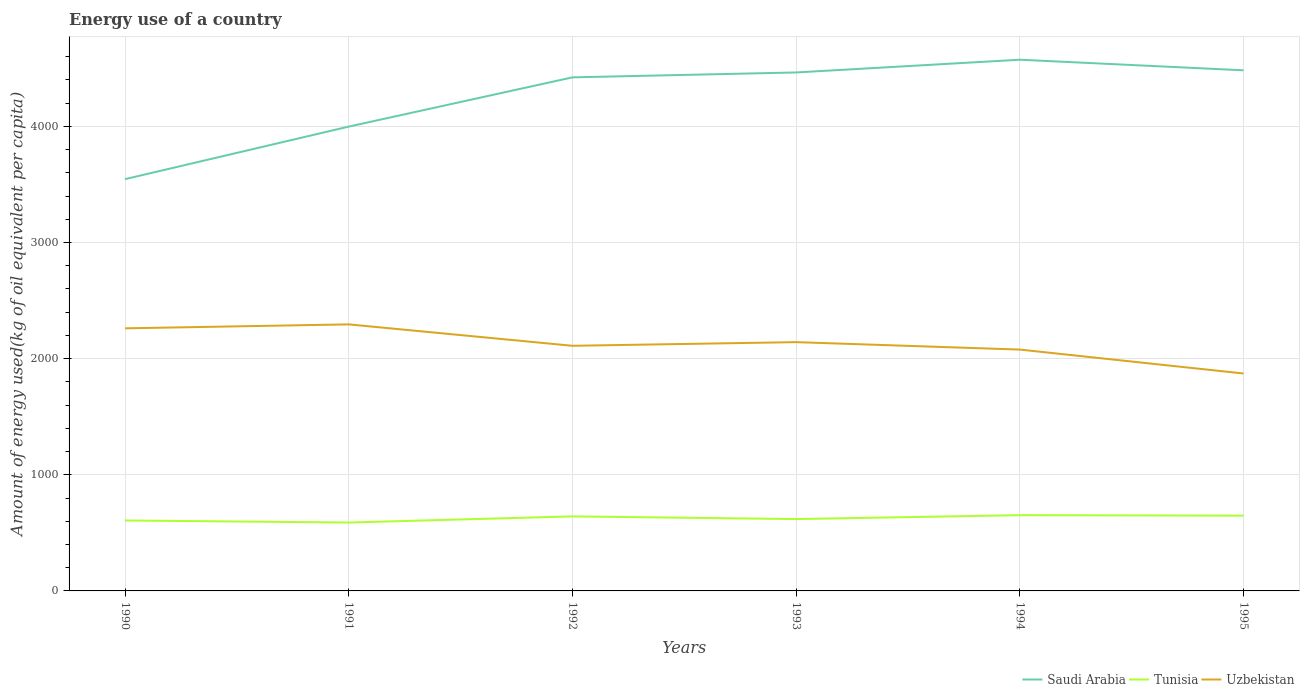How many different coloured lines are there?
Provide a short and direct response. 3. Is the number of lines equal to the number of legend labels?
Your answer should be very brief. Yes. Across all years, what is the maximum amount of energy used in in Saudi Arabia?
Ensure brevity in your answer.  3545.24. In which year was the amount of energy used in in Uzbekistan maximum?
Your answer should be compact. 1995. What is the total amount of energy used in in Tunisia in the graph?
Offer a very short reply. -12.02. What is the difference between the highest and the second highest amount of energy used in in Saudi Arabia?
Keep it short and to the point. 1028.2. What is the difference between the highest and the lowest amount of energy used in in Tunisia?
Offer a very short reply. 3. Is the amount of energy used in in Saudi Arabia strictly greater than the amount of energy used in in Uzbekistan over the years?
Your answer should be compact. No. How many lines are there?
Provide a succinct answer. 3. How many years are there in the graph?
Your response must be concise. 6. What is the difference between two consecutive major ticks on the Y-axis?
Your answer should be very brief. 1000. Are the values on the major ticks of Y-axis written in scientific E-notation?
Offer a very short reply. No. Does the graph contain grids?
Offer a very short reply. Yes. How many legend labels are there?
Offer a very short reply. 3. How are the legend labels stacked?
Your answer should be compact. Horizontal. What is the title of the graph?
Offer a very short reply. Energy use of a country. What is the label or title of the Y-axis?
Offer a terse response. Amount of energy used(kg of oil equivalent per capita). What is the Amount of energy used(kg of oil equivalent per capita) in Saudi Arabia in 1990?
Offer a very short reply. 3545.24. What is the Amount of energy used(kg of oil equivalent per capita) of Tunisia in 1990?
Keep it short and to the point. 606.56. What is the Amount of energy used(kg of oil equivalent per capita) of Uzbekistan in 1990?
Make the answer very short. 2260.77. What is the Amount of energy used(kg of oil equivalent per capita) of Saudi Arabia in 1991?
Your answer should be very brief. 3997.62. What is the Amount of energy used(kg of oil equivalent per capita) of Tunisia in 1991?
Make the answer very short. 588.87. What is the Amount of energy used(kg of oil equivalent per capita) of Uzbekistan in 1991?
Your answer should be compact. 2294.82. What is the Amount of energy used(kg of oil equivalent per capita) of Saudi Arabia in 1992?
Make the answer very short. 4421.51. What is the Amount of energy used(kg of oil equivalent per capita) in Tunisia in 1992?
Give a very brief answer. 641.69. What is the Amount of energy used(kg of oil equivalent per capita) in Uzbekistan in 1992?
Give a very brief answer. 2110.5. What is the Amount of energy used(kg of oil equivalent per capita) in Saudi Arabia in 1993?
Keep it short and to the point. 4463.81. What is the Amount of energy used(kg of oil equivalent per capita) in Tunisia in 1993?
Your answer should be compact. 618.59. What is the Amount of energy used(kg of oil equivalent per capita) in Uzbekistan in 1993?
Your answer should be very brief. 2141.93. What is the Amount of energy used(kg of oil equivalent per capita) in Saudi Arabia in 1994?
Offer a very short reply. 4573.44. What is the Amount of energy used(kg of oil equivalent per capita) of Tunisia in 1994?
Provide a short and direct response. 652.31. What is the Amount of energy used(kg of oil equivalent per capita) in Uzbekistan in 1994?
Offer a terse response. 2077.89. What is the Amount of energy used(kg of oil equivalent per capita) in Saudi Arabia in 1995?
Your answer should be very brief. 4482.28. What is the Amount of energy used(kg of oil equivalent per capita) in Tunisia in 1995?
Your response must be concise. 647.98. What is the Amount of energy used(kg of oil equivalent per capita) in Uzbekistan in 1995?
Make the answer very short. 1871.85. Across all years, what is the maximum Amount of energy used(kg of oil equivalent per capita) of Saudi Arabia?
Provide a succinct answer. 4573.44. Across all years, what is the maximum Amount of energy used(kg of oil equivalent per capita) in Tunisia?
Offer a terse response. 652.31. Across all years, what is the maximum Amount of energy used(kg of oil equivalent per capita) of Uzbekistan?
Ensure brevity in your answer.  2294.82. Across all years, what is the minimum Amount of energy used(kg of oil equivalent per capita) in Saudi Arabia?
Offer a very short reply. 3545.24. Across all years, what is the minimum Amount of energy used(kg of oil equivalent per capita) of Tunisia?
Make the answer very short. 588.87. Across all years, what is the minimum Amount of energy used(kg of oil equivalent per capita) in Uzbekistan?
Your response must be concise. 1871.85. What is the total Amount of energy used(kg of oil equivalent per capita) in Saudi Arabia in the graph?
Make the answer very short. 2.55e+04. What is the total Amount of energy used(kg of oil equivalent per capita) of Tunisia in the graph?
Your response must be concise. 3756.01. What is the total Amount of energy used(kg of oil equivalent per capita) in Uzbekistan in the graph?
Ensure brevity in your answer.  1.28e+04. What is the difference between the Amount of energy used(kg of oil equivalent per capita) of Saudi Arabia in 1990 and that in 1991?
Provide a short and direct response. -452.37. What is the difference between the Amount of energy used(kg of oil equivalent per capita) in Tunisia in 1990 and that in 1991?
Offer a terse response. 17.7. What is the difference between the Amount of energy used(kg of oil equivalent per capita) in Uzbekistan in 1990 and that in 1991?
Keep it short and to the point. -34.06. What is the difference between the Amount of energy used(kg of oil equivalent per capita) of Saudi Arabia in 1990 and that in 1992?
Provide a succinct answer. -876.27. What is the difference between the Amount of energy used(kg of oil equivalent per capita) in Tunisia in 1990 and that in 1992?
Offer a very short reply. -35.13. What is the difference between the Amount of energy used(kg of oil equivalent per capita) in Uzbekistan in 1990 and that in 1992?
Your response must be concise. 150.27. What is the difference between the Amount of energy used(kg of oil equivalent per capita) of Saudi Arabia in 1990 and that in 1993?
Give a very brief answer. -918.57. What is the difference between the Amount of energy used(kg of oil equivalent per capita) in Tunisia in 1990 and that in 1993?
Offer a very short reply. -12.02. What is the difference between the Amount of energy used(kg of oil equivalent per capita) of Uzbekistan in 1990 and that in 1993?
Ensure brevity in your answer.  118.83. What is the difference between the Amount of energy used(kg of oil equivalent per capita) in Saudi Arabia in 1990 and that in 1994?
Provide a succinct answer. -1028.2. What is the difference between the Amount of energy used(kg of oil equivalent per capita) in Tunisia in 1990 and that in 1994?
Give a very brief answer. -45.75. What is the difference between the Amount of energy used(kg of oil equivalent per capita) in Uzbekistan in 1990 and that in 1994?
Offer a terse response. 182.88. What is the difference between the Amount of energy used(kg of oil equivalent per capita) of Saudi Arabia in 1990 and that in 1995?
Ensure brevity in your answer.  -937.04. What is the difference between the Amount of energy used(kg of oil equivalent per capita) of Tunisia in 1990 and that in 1995?
Offer a terse response. -41.42. What is the difference between the Amount of energy used(kg of oil equivalent per capita) in Uzbekistan in 1990 and that in 1995?
Provide a succinct answer. 388.92. What is the difference between the Amount of energy used(kg of oil equivalent per capita) of Saudi Arabia in 1991 and that in 1992?
Make the answer very short. -423.89. What is the difference between the Amount of energy used(kg of oil equivalent per capita) of Tunisia in 1991 and that in 1992?
Your response must be concise. -52.82. What is the difference between the Amount of energy used(kg of oil equivalent per capita) in Uzbekistan in 1991 and that in 1992?
Your response must be concise. 184.33. What is the difference between the Amount of energy used(kg of oil equivalent per capita) in Saudi Arabia in 1991 and that in 1993?
Provide a short and direct response. -466.19. What is the difference between the Amount of energy used(kg of oil equivalent per capita) of Tunisia in 1991 and that in 1993?
Offer a very short reply. -29.72. What is the difference between the Amount of energy used(kg of oil equivalent per capita) of Uzbekistan in 1991 and that in 1993?
Provide a succinct answer. 152.89. What is the difference between the Amount of energy used(kg of oil equivalent per capita) in Saudi Arabia in 1991 and that in 1994?
Your response must be concise. -575.83. What is the difference between the Amount of energy used(kg of oil equivalent per capita) in Tunisia in 1991 and that in 1994?
Keep it short and to the point. -63.45. What is the difference between the Amount of energy used(kg of oil equivalent per capita) of Uzbekistan in 1991 and that in 1994?
Ensure brevity in your answer.  216.93. What is the difference between the Amount of energy used(kg of oil equivalent per capita) of Saudi Arabia in 1991 and that in 1995?
Make the answer very short. -484.67. What is the difference between the Amount of energy used(kg of oil equivalent per capita) in Tunisia in 1991 and that in 1995?
Offer a very short reply. -59.12. What is the difference between the Amount of energy used(kg of oil equivalent per capita) in Uzbekistan in 1991 and that in 1995?
Offer a very short reply. 422.97. What is the difference between the Amount of energy used(kg of oil equivalent per capita) of Saudi Arabia in 1992 and that in 1993?
Your answer should be compact. -42.3. What is the difference between the Amount of energy used(kg of oil equivalent per capita) in Tunisia in 1992 and that in 1993?
Your response must be concise. 23.1. What is the difference between the Amount of energy used(kg of oil equivalent per capita) of Uzbekistan in 1992 and that in 1993?
Your response must be concise. -31.44. What is the difference between the Amount of energy used(kg of oil equivalent per capita) of Saudi Arabia in 1992 and that in 1994?
Ensure brevity in your answer.  -151.94. What is the difference between the Amount of energy used(kg of oil equivalent per capita) of Tunisia in 1992 and that in 1994?
Keep it short and to the point. -10.62. What is the difference between the Amount of energy used(kg of oil equivalent per capita) in Uzbekistan in 1992 and that in 1994?
Give a very brief answer. 32.6. What is the difference between the Amount of energy used(kg of oil equivalent per capita) of Saudi Arabia in 1992 and that in 1995?
Your answer should be very brief. -60.78. What is the difference between the Amount of energy used(kg of oil equivalent per capita) in Tunisia in 1992 and that in 1995?
Provide a short and direct response. -6.29. What is the difference between the Amount of energy used(kg of oil equivalent per capita) in Uzbekistan in 1992 and that in 1995?
Keep it short and to the point. 238.64. What is the difference between the Amount of energy used(kg of oil equivalent per capita) of Saudi Arabia in 1993 and that in 1994?
Ensure brevity in your answer.  -109.64. What is the difference between the Amount of energy used(kg of oil equivalent per capita) in Tunisia in 1993 and that in 1994?
Make the answer very short. -33.73. What is the difference between the Amount of energy used(kg of oil equivalent per capita) of Uzbekistan in 1993 and that in 1994?
Your answer should be compact. 64.04. What is the difference between the Amount of energy used(kg of oil equivalent per capita) in Saudi Arabia in 1993 and that in 1995?
Your answer should be compact. -18.48. What is the difference between the Amount of energy used(kg of oil equivalent per capita) in Tunisia in 1993 and that in 1995?
Make the answer very short. -29.4. What is the difference between the Amount of energy used(kg of oil equivalent per capita) in Uzbekistan in 1993 and that in 1995?
Make the answer very short. 270.08. What is the difference between the Amount of energy used(kg of oil equivalent per capita) in Saudi Arabia in 1994 and that in 1995?
Your answer should be compact. 91.16. What is the difference between the Amount of energy used(kg of oil equivalent per capita) in Tunisia in 1994 and that in 1995?
Make the answer very short. 4.33. What is the difference between the Amount of energy used(kg of oil equivalent per capita) of Uzbekistan in 1994 and that in 1995?
Offer a terse response. 206.04. What is the difference between the Amount of energy used(kg of oil equivalent per capita) in Saudi Arabia in 1990 and the Amount of energy used(kg of oil equivalent per capita) in Tunisia in 1991?
Offer a very short reply. 2956.38. What is the difference between the Amount of energy used(kg of oil equivalent per capita) of Saudi Arabia in 1990 and the Amount of energy used(kg of oil equivalent per capita) of Uzbekistan in 1991?
Your answer should be very brief. 1250.42. What is the difference between the Amount of energy used(kg of oil equivalent per capita) in Tunisia in 1990 and the Amount of energy used(kg of oil equivalent per capita) in Uzbekistan in 1991?
Make the answer very short. -1688.26. What is the difference between the Amount of energy used(kg of oil equivalent per capita) of Saudi Arabia in 1990 and the Amount of energy used(kg of oil equivalent per capita) of Tunisia in 1992?
Give a very brief answer. 2903.55. What is the difference between the Amount of energy used(kg of oil equivalent per capita) in Saudi Arabia in 1990 and the Amount of energy used(kg of oil equivalent per capita) in Uzbekistan in 1992?
Provide a short and direct response. 1434.75. What is the difference between the Amount of energy used(kg of oil equivalent per capita) of Tunisia in 1990 and the Amount of energy used(kg of oil equivalent per capita) of Uzbekistan in 1992?
Make the answer very short. -1503.93. What is the difference between the Amount of energy used(kg of oil equivalent per capita) of Saudi Arabia in 1990 and the Amount of energy used(kg of oil equivalent per capita) of Tunisia in 1993?
Your response must be concise. 2926.65. What is the difference between the Amount of energy used(kg of oil equivalent per capita) of Saudi Arabia in 1990 and the Amount of energy used(kg of oil equivalent per capita) of Uzbekistan in 1993?
Your response must be concise. 1403.31. What is the difference between the Amount of energy used(kg of oil equivalent per capita) in Tunisia in 1990 and the Amount of energy used(kg of oil equivalent per capita) in Uzbekistan in 1993?
Provide a succinct answer. -1535.37. What is the difference between the Amount of energy used(kg of oil equivalent per capita) of Saudi Arabia in 1990 and the Amount of energy used(kg of oil equivalent per capita) of Tunisia in 1994?
Provide a succinct answer. 2892.93. What is the difference between the Amount of energy used(kg of oil equivalent per capita) in Saudi Arabia in 1990 and the Amount of energy used(kg of oil equivalent per capita) in Uzbekistan in 1994?
Your response must be concise. 1467.35. What is the difference between the Amount of energy used(kg of oil equivalent per capita) in Tunisia in 1990 and the Amount of energy used(kg of oil equivalent per capita) in Uzbekistan in 1994?
Ensure brevity in your answer.  -1471.33. What is the difference between the Amount of energy used(kg of oil equivalent per capita) in Saudi Arabia in 1990 and the Amount of energy used(kg of oil equivalent per capita) in Tunisia in 1995?
Make the answer very short. 2897.26. What is the difference between the Amount of energy used(kg of oil equivalent per capita) of Saudi Arabia in 1990 and the Amount of energy used(kg of oil equivalent per capita) of Uzbekistan in 1995?
Offer a terse response. 1673.39. What is the difference between the Amount of energy used(kg of oil equivalent per capita) in Tunisia in 1990 and the Amount of energy used(kg of oil equivalent per capita) in Uzbekistan in 1995?
Offer a very short reply. -1265.29. What is the difference between the Amount of energy used(kg of oil equivalent per capita) in Saudi Arabia in 1991 and the Amount of energy used(kg of oil equivalent per capita) in Tunisia in 1992?
Ensure brevity in your answer.  3355.93. What is the difference between the Amount of energy used(kg of oil equivalent per capita) of Saudi Arabia in 1991 and the Amount of energy used(kg of oil equivalent per capita) of Uzbekistan in 1992?
Give a very brief answer. 1887.12. What is the difference between the Amount of energy used(kg of oil equivalent per capita) in Tunisia in 1991 and the Amount of energy used(kg of oil equivalent per capita) in Uzbekistan in 1992?
Give a very brief answer. -1521.63. What is the difference between the Amount of energy used(kg of oil equivalent per capita) in Saudi Arabia in 1991 and the Amount of energy used(kg of oil equivalent per capita) in Tunisia in 1993?
Keep it short and to the point. 3379.03. What is the difference between the Amount of energy used(kg of oil equivalent per capita) of Saudi Arabia in 1991 and the Amount of energy used(kg of oil equivalent per capita) of Uzbekistan in 1993?
Give a very brief answer. 1855.68. What is the difference between the Amount of energy used(kg of oil equivalent per capita) in Tunisia in 1991 and the Amount of energy used(kg of oil equivalent per capita) in Uzbekistan in 1993?
Keep it short and to the point. -1553.07. What is the difference between the Amount of energy used(kg of oil equivalent per capita) in Saudi Arabia in 1991 and the Amount of energy used(kg of oil equivalent per capita) in Tunisia in 1994?
Keep it short and to the point. 3345.3. What is the difference between the Amount of energy used(kg of oil equivalent per capita) of Saudi Arabia in 1991 and the Amount of energy used(kg of oil equivalent per capita) of Uzbekistan in 1994?
Ensure brevity in your answer.  1919.72. What is the difference between the Amount of energy used(kg of oil equivalent per capita) of Tunisia in 1991 and the Amount of energy used(kg of oil equivalent per capita) of Uzbekistan in 1994?
Provide a short and direct response. -1489.02. What is the difference between the Amount of energy used(kg of oil equivalent per capita) of Saudi Arabia in 1991 and the Amount of energy used(kg of oil equivalent per capita) of Tunisia in 1995?
Keep it short and to the point. 3349.63. What is the difference between the Amount of energy used(kg of oil equivalent per capita) in Saudi Arabia in 1991 and the Amount of energy used(kg of oil equivalent per capita) in Uzbekistan in 1995?
Offer a very short reply. 2125.76. What is the difference between the Amount of energy used(kg of oil equivalent per capita) of Tunisia in 1991 and the Amount of energy used(kg of oil equivalent per capita) of Uzbekistan in 1995?
Keep it short and to the point. -1282.98. What is the difference between the Amount of energy used(kg of oil equivalent per capita) of Saudi Arabia in 1992 and the Amount of energy used(kg of oil equivalent per capita) of Tunisia in 1993?
Your answer should be compact. 3802.92. What is the difference between the Amount of energy used(kg of oil equivalent per capita) of Saudi Arabia in 1992 and the Amount of energy used(kg of oil equivalent per capita) of Uzbekistan in 1993?
Offer a terse response. 2279.58. What is the difference between the Amount of energy used(kg of oil equivalent per capita) of Tunisia in 1992 and the Amount of energy used(kg of oil equivalent per capita) of Uzbekistan in 1993?
Ensure brevity in your answer.  -1500.24. What is the difference between the Amount of energy used(kg of oil equivalent per capita) of Saudi Arabia in 1992 and the Amount of energy used(kg of oil equivalent per capita) of Tunisia in 1994?
Give a very brief answer. 3769.19. What is the difference between the Amount of energy used(kg of oil equivalent per capita) of Saudi Arabia in 1992 and the Amount of energy used(kg of oil equivalent per capita) of Uzbekistan in 1994?
Keep it short and to the point. 2343.62. What is the difference between the Amount of energy used(kg of oil equivalent per capita) in Tunisia in 1992 and the Amount of energy used(kg of oil equivalent per capita) in Uzbekistan in 1994?
Give a very brief answer. -1436.2. What is the difference between the Amount of energy used(kg of oil equivalent per capita) in Saudi Arabia in 1992 and the Amount of energy used(kg of oil equivalent per capita) in Tunisia in 1995?
Keep it short and to the point. 3773.52. What is the difference between the Amount of energy used(kg of oil equivalent per capita) of Saudi Arabia in 1992 and the Amount of energy used(kg of oil equivalent per capita) of Uzbekistan in 1995?
Ensure brevity in your answer.  2549.66. What is the difference between the Amount of energy used(kg of oil equivalent per capita) of Tunisia in 1992 and the Amount of energy used(kg of oil equivalent per capita) of Uzbekistan in 1995?
Your answer should be very brief. -1230.16. What is the difference between the Amount of energy used(kg of oil equivalent per capita) of Saudi Arabia in 1993 and the Amount of energy used(kg of oil equivalent per capita) of Tunisia in 1994?
Offer a terse response. 3811.49. What is the difference between the Amount of energy used(kg of oil equivalent per capita) of Saudi Arabia in 1993 and the Amount of energy used(kg of oil equivalent per capita) of Uzbekistan in 1994?
Provide a short and direct response. 2385.92. What is the difference between the Amount of energy used(kg of oil equivalent per capita) of Tunisia in 1993 and the Amount of energy used(kg of oil equivalent per capita) of Uzbekistan in 1994?
Offer a terse response. -1459.3. What is the difference between the Amount of energy used(kg of oil equivalent per capita) in Saudi Arabia in 1993 and the Amount of energy used(kg of oil equivalent per capita) in Tunisia in 1995?
Keep it short and to the point. 3815.82. What is the difference between the Amount of energy used(kg of oil equivalent per capita) of Saudi Arabia in 1993 and the Amount of energy used(kg of oil equivalent per capita) of Uzbekistan in 1995?
Make the answer very short. 2591.96. What is the difference between the Amount of energy used(kg of oil equivalent per capita) of Tunisia in 1993 and the Amount of energy used(kg of oil equivalent per capita) of Uzbekistan in 1995?
Provide a short and direct response. -1253.26. What is the difference between the Amount of energy used(kg of oil equivalent per capita) in Saudi Arabia in 1994 and the Amount of energy used(kg of oil equivalent per capita) in Tunisia in 1995?
Offer a terse response. 3925.46. What is the difference between the Amount of energy used(kg of oil equivalent per capita) in Saudi Arabia in 1994 and the Amount of energy used(kg of oil equivalent per capita) in Uzbekistan in 1995?
Offer a terse response. 2701.59. What is the difference between the Amount of energy used(kg of oil equivalent per capita) of Tunisia in 1994 and the Amount of energy used(kg of oil equivalent per capita) of Uzbekistan in 1995?
Provide a short and direct response. -1219.54. What is the average Amount of energy used(kg of oil equivalent per capita) in Saudi Arabia per year?
Keep it short and to the point. 4247.32. What is the average Amount of energy used(kg of oil equivalent per capita) in Tunisia per year?
Make the answer very short. 626. What is the average Amount of energy used(kg of oil equivalent per capita) of Uzbekistan per year?
Give a very brief answer. 2126.29. In the year 1990, what is the difference between the Amount of energy used(kg of oil equivalent per capita) in Saudi Arabia and Amount of energy used(kg of oil equivalent per capita) in Tunisia?
Keep it short and to the point. 2938.68. In the year 1990, what is the difference between the Amount of energy used(kg of oil equivalent per capita) in Saudi Arabia and Amount of energy used(kg of oil equivalent per capita) in Uzbekistan?
Offer a very short reply. 1284.47. In the year 1990, what is the difference between the Amount of energy used(kg of oil equivalent per capita) in Tunisia and Amount of energy used(kg of oil equivalent per capita) in Uzbekistan?
Offer a very short reply. -1654.2. In the year 1991, what is the difference between the Amount of energy used(kg of oil equivalent per capita) in Saudi Arabia and Amount of energy used(kg of oil equivalent per capita) in Tunisia?
Offer a terse response. 3408.75. In the year 1991, what is the difference between the Amount of energy used(kg of oil equivalent per capita) in Saudi Arabia and Amount of energy used(kg of oil equivalent per capita) in Uzbekistan?
Ensure brevity in your answer.  1702.79. In the year 1991, what is the difference between the Amount of energy used(kg of oil equivalent per capita) in Tunisia and Amount of energy used(kg of oil equivalent per capita) in Uzbekistan?
Give a very brief answer. -1705.96. In the year 1992, what is the difference between the Amount of energy used(kg of oil equivalent per capita) in Saudi Arabia and Amount of energy used(kg of oil equivalent per capita) in Tunisia?
Your answer should be very brief. 3779.82. In the year 1992, what is the difference between the Amount of energy used(kg of oil equivalent per capita) of Saudi Arabia and Amount of energy used(kg of oil equivalent per capita) of Uzbekistan?
Offer a very short reply. 2311.01. In the year 1992, what is the difference between the Amount of energy used(kg of oil equivalent per capita) in Tunisia and Amount of energy used(kg of oil equivalent per capita) in Uzbekistan?
Ensure brevity in your answer.  -1468.81. In the year 1993, what is the difference between the Amount of energy used(kg of oil equivalent per capita) in Saudi Arabia and Amount of energy used(kg of oil equivalent per capita) in Tunisia?
Provide a short and direct response. 3845.22. In the year 1993, what is the difference between the Amount of energy used(kg of oil equivalent per capita) of Saudi Arabia and Amount of energy used(kg of oil equivalent per capita) of Uzbekistan?
Provide a succinct answer. 2321.87. In the year 1993, what is the difference between the Amount of energy used(kg of oil equivalent per capita) of Tunisia and Amount of energy used(kg of oil equivalent per capita) of Uzbekistan?
Your response must be concise. -1523.35. In the year 1994, what is the difference between the Amount of energy used(kg of oil equivalent per capita) in Saudi Arabia and Amount of energy used(kg of oil equivalent per capita) in Tunisia?
Your response must be concise. 3921.13. In the year 1994, what is the difference between the Amount of energy used(kg of oil equivalent per capita) of Saudi Arabia and Amount of energy used(kg of oil equivalent per capita) of Uzbekistan?
Offer a terse response. 2495.55. In the year 1994, what is the difference between the Amount of energy used(kg of oil equivalent per capita) in Tunisia and Amount of energy used(kg of oil equivalent per capita) in Uzbekistan?
Give a very brief answer. -1425.58. In the year 1995, what is the difference between the Amount of energy used(kg of oil equivalent per capita) of Saudi Arabia and Amount of energy used(kg of oil equivalent per capita) of Tunisia?
Ensure brevity in your answer.  3834.3. In the year 1995, what is the difference between the Amount of energy used(kg of oil equivalent per capita) in Saudi Arabia and Amount of energy used(kg of oil equivalent per capita) in Uzbekistan?
Your answer should be very brief. 2610.43. In the year 1995, what is the difference between the Amount of energy used(kg of oil equivalent per capita) in Tunisia and Amount of energy used(kg of oil equivalent per capita) in Uzbekistan?
Give a very brief answer. -1223.87. What is the ratio of the Amount of energy used(kg of oil equivalent per capita) of Saudi Arabia in 1990 to that in 1991?
Your answer should be very brief. 0.89. What is the ratio of the Amount of energy used(kg of oil equivalent per capita) of Tunisia in 1990 to that in 1991?
Offer a terse response. 1.03. What is the ratio of the Amount of energy used(kg of oil equivalent per capita) of Uzbekistan in 1990 to that in 1991?
Keep it short and to the point. 0.99. What is the ratio of the Amount of energy used(kg of oil equivalent per capita) of Saudi Arabia in 1990 to that in 1992?
Make the answer very short. 0.8. What is the ratio of the Amount of energy used(kg of oil equivalent per capita) of Tunisia in 1990 to that in 1992?
Your answer should be very brief. 0.95. What is the ratio of the Amount of energy used(kg of oil equivalent per capita) in Uzbekistan in 1990 to that in 1992?
Keep it short and to the point. 1.07. What is the ratio of the Amount of energy used(kg of oil equivalent per capita) of Saudi Arabia in 1990 to that in 1993?
Provide a short and direct response. 0.79. What is the ratio of the Amount of energy used(kg of oil equivalent per capita) of Tunisia in 1990 to that in 1993?
Offer a very short reply. 0.98. What is the ratio of the Amount of energy used(kg of oil equivalent per capita) in Uzbekistan in 1990 to that in 1993?
Provide a succinct answer. 1.06. What is the ratio of the Amount of energy used(kg of oil equivalent per capita) of Saudi Arabia in 1990 to that in 1994?
Offer a terse response. 0.78. What is the ratio of the Amount of energy used(kg of oil equivalent per capita) of Tunisia in 1990 to that in 1994?
Offer a very short reply. 0.93. What is the ratio of the Amount of energy used(kg of oil equivalent per capita) in Uzbekistan in 1990 to that in 1994?
Provide a short and direct response. 1.09. What is the ratio of the Amount of energy used(kg of oil equivalent per capita) in Saudi Arabia in 1990 to that in 1995?
Offer a very short reply. 0.79. What is the ratio of the Amount of energy used(kg of oil equivalent per capita) of Tunisia in 1990 to that in 1995?
Provide a succinct answer. 0.94. What is the ratio of the Amount of energy used(kg of oil equivalent per capita) in Uzbekistan in 1990 to that in 1995?
Make the answer very short. 1.21. What is the ratio of the Amount of energy used(kg of oil equivalent per capita) of Saudi Arabia in 1991 to that in 1992?
Offer a very short reply. 0.9. What is the ratio of the Amount of energy used(kg of oil equivalent per capita) of Tunisia in 1991 to that in 1992?
Your answer should be very brief. 0.92. What is the ratio of the Amount of energy used(kg of oil equivalent per capita) of Uzbekistan in 1991 to that in 1992?
Keep it short and to the point. 1.09. What is the ratio of the Amount of energy used(kg of oil equivalent per capita) of Saudi Arabia in 1991 to that in 1993?
Ensure brevity in your answer.  0.9. What is the ratio of the Amount of energy used(kg of oil equivalent per capita) in Tunisia in 1991 to that in 1993?
Make the answer very short. 0.95. What is the ratio of the Amount of energy used(kg of oil equivalent per capita) in Uzbekistan in 1991 to that in 1993?
Your response must be concise. 1.07. What is the ratio of the Amount of energy used(kg of oil equivalent per capita) of Saudi Arabia in 1991 to that in 1994?
Ensure brevity in your answer.  0.87. What is the ratio of the Amount of energy used(kg of oil equivalent per capita) in Tunisia in 1991 to that in 1994?
Ensure brevity in your answer.  0.9. What is the ratio of the Amount of energy used(kg of oil equivalent per capita) of Uzbekistan in 1991 to that in 1994?
Offer a terse response. 1.1. What is the ratio of the Amount of energy used(kg of oil equivalent per capita) of Saudi Arabia in 1991 to that in 1995?
Your answer should be very brief. 0.89. What is the ratio of the Amount of energy used(kg of oil equivalent per capita) of Tunisia in 1991 to that in 1995?
Ensure brevity in your answer.  0.91. What is the ratio of the Amount of energy used(kg of oil equivalent per capita) in Uzbekistan in 1991 to that in 1995?
Offer a terse response. 1.23. What is the ratio of the Amount of energy used(kg of oil equivalent per capita) in Saudi Arabia in 1992 to that in 1993?
Your answer should be compact. 0.99. What is the ratio of the Amount of energy used(kg of oil equivalent per capita) of Tunisia in 1992 to that in 1993?
Give a very brief answer. 1.04. What is the ratio of the Amount of energy used(kg of oil equivalent per capita) in Uzbekistan in 1992 to that in 1993?
Keep it short and to the point. 0.99. What is the ratio of the Amount of energy used(kg of oil equivalent per capita) in Saudi Arabia in 1992 to that in 1994?
Make the answer very short. 0.97. What is the ratio of the Amount of energy used(kg of oil equivalent per capita) of Tunisia in 1992 to that in 1994?
Offer a terse response. 0.98. What is the ratio of the Amount of energy used(kg of oil equivalent per capita) of Uzbekistan in 1992 to that in 1994?
Your response must be concise. 1.02. What is the ratio of the Amount of energy used(kg of oil equivalent per capita) of Saudi Arabia in 1992 to that in 1995?
Give a very brief answer. 0.99. What is the ratio of the Amount of energy used(kg of oil equivalent per capita) of Tunisia in 1992 to that in 1995?
Give a very brief answer. 0.99. What is the ratio of the Amount of energy used(kg of oil equivalent per capita) in Uzbekistan in 1992 to that in 1995?
Provide a short and direct response. 1.13. What is the ratio of the Amount of energy used(kg of oil equivalent per capita) of Saudi Arabia in 1993 to that in 1994?
Provide a succinct answer. 0.98. What is the ratio of the Amount of energy used(kg of oil equivalent per capita) of Tunisia in 1993 to that in 1994?
Give a very brief answer. 0.95. What is the ratio of the Amount of energy used(kg of oil equivalent per capita) in Uzbekistan in 1993 to that in 1994?
Offer a very short reply. 1.03. What is the ratio of the Amount of energy used(kg of oil equivalent per capita) in Tunisia in 1993 to that in 1995?
Provide a succinct answer. 0.95. What is the ratio of the Amount of energy used(kg of oil equivalent per capita) in Uzbekistan in 1993 to that in 1995?
Offer a very short reply. 1.14. What is the ratio of the Amount of energy used(kg of oil equivalent per capita) in Saudi Arabia in 1994 to that in 1995?
Ensure brevity in your answer.  1.02. What is the ratio of the Amount of energy used(kg of oil equivalent per capita) in Uzbekistan in 1994 to that in 1995?
Your answer should be compact. 1.11. What is the difference between the highest and the second highest Amount of energy used(kg of oil equivalent per capita) in Saudi Arabia?
Ensure brevity in your answer.  91.16. What is the difference between the highest and the second highest Amount of energy used(kg of oil equivalent per capita) of Tunisia?
Your response must be concise. 4.33. What is the difference between the highest and the second highest Amount of energy used(kg of oil equivalent per capita) in Uzbekistan?
Your answer should be very brief. 34.06. What is the difference between the highest and the lowest Amount of energy used(kg of oil equivalent per capita) of Saudi Arabia?
Offer a terse response. 1028.2. What is the difference between the highest and the lowest Amount of energy used(kg of oil equivalent per capita) in Tunisia?
Offer a very short reply. 63.45. What is the difference between the highest and the lowest Amount of energy used(kg of oil equivalent per capita) of Uzbekistan?
Ensure brevity in your answer.  422.97. 